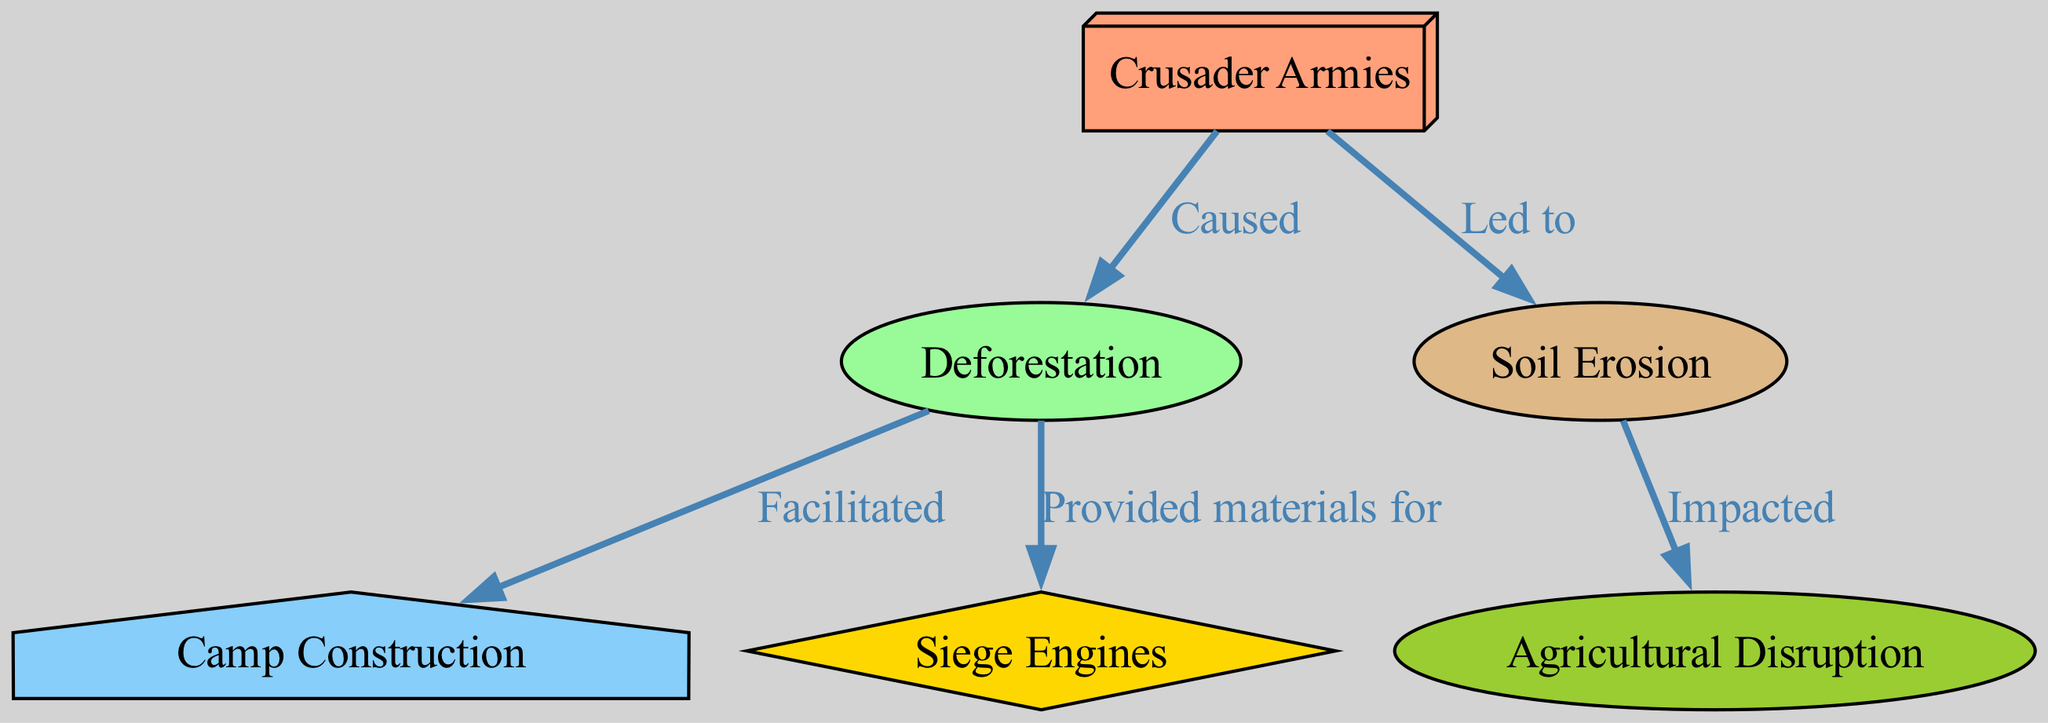What are the total number of nodes in the diagram? The diagram contains six distinct nodes: Crusader Armies, Deforestation, Soil Erosion, Camp Construction, Siege Engines, and Agricultural Disruption.
Answer: 6 What relationship does the Crusader Armies have with Deforestation? The diagram shows a directed edge from Crusader Armies to Deforestation with the label "Caused," indicating that the Crusader Armies caused deforestation.
Answer: Caused Which node is impacted by Soil Erosion? According to the diagram, Soil Erosion has a directed edge leading to the node Agricultural Disruption with the label "Impacted," meaning that soil erosion directly impacts agriculture.
Answer: Agriculture What does Deforestation facilitate? The edge pointing from Deforestation to Camp Construction is labeled "Facilitated," so deforestation facilitates the construction of camps by the armies.
Answer: Camp Construction What materials did Deforestation provide? The diagram illustrates that Deforestation provided materials for Siege Engines, as indicated by the directed edge labeled "Provided materials for."
Answer: Siege Engines How does the movement of Crusader Armies ultimately affect agriculture? The flow in the diagram indicates that the Crusader Armies caused deforestation, which led to soil erosion, and this erosion ultimately impacted agriculture. This reasoning connects multiple edges to arrive at the comprehensive impact.
Answer: Agriculture 